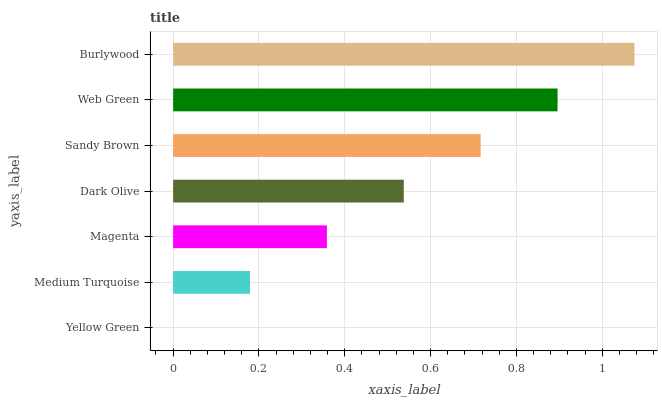Is Yellow Green the minimum?
Answer yes or no. Yes. Is Burlywood the maximum?
Answer yes or no. Yes. Is Medium Turquoise the minimum?
Answer yes or no. No. Is Medium Turquoise the maximum?
Answer yes or no. No. Is Medium Turquoise greater than Yellow Green?
Answer yes or no. Yes. Is Yellow Green less than Medium Turquoise?
Answer yes or no. Yes. Is Yellow Green greater than Medium Turquoise?
Answer yes or no. No. Is Medium Turquoise less than Yellow Green?
Answer yes or no. No. Is Dark Olive the high median?
Answer yes or no. Yes. Is Dark Olive the low median?
Answer yes or no. Yes. Is Magenta the high median?
Answer yes or no. No. Is Burlywood the low median?
Answer yes or no. No. 